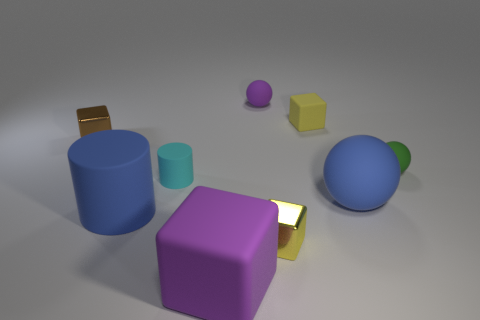Subtract all cyan spheres. How many yellow cubes are left? 2 Subtract all small balls. How many balls are left? 1 Subtract all brown blocks. How many blocks are left? 3 Subtract 1 blocks. How many blocks are left? 3 Add 1 green things. How many objects exist? 10 Subtract all gray blocks. Subtract all green spheres. How many blocks are left? 4 Subtract all spheres. How many objects are left? 6 Add 3 tiny cylinders. How many tiny cylinders exist? 4 Subtract 0 red cylinders. How many objects are left? 9 Subtract all small purple metal things. Subtract all small green objects. How many objects are left? 8 